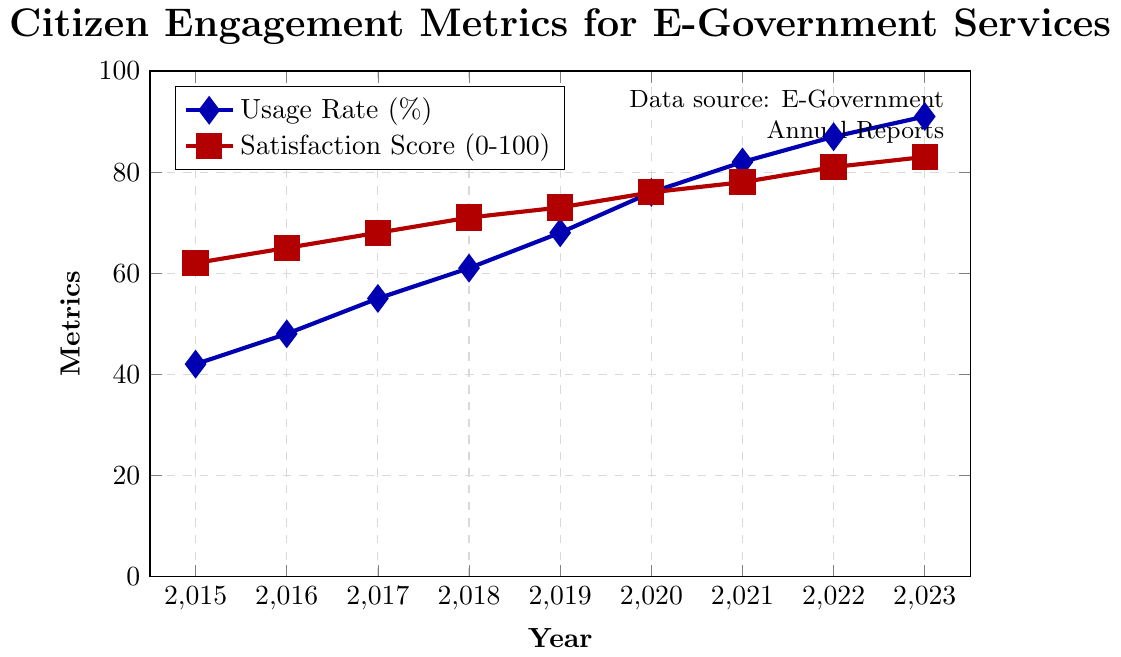What is the trend observed in the usage rate of e-government services from 2015 to 2023? Observing the blue line for Usage Rate (%), it shows a steady upward trend from 42% in 2015 to 91% in 2023. This indicates a consistent increase in usage rates over the years.
Answer: Steady upward trend Compare the Satisfaction Score of 2015 to that of 2023. The red line for Satisfaction Score in 2015 is at 62%, while in 2023 it reaches 83%. Hence, the satisfaction score increased by 21 percentage points over this period.
Answer: Increased by 21 percentage points Which year shows the highest increase in the usage rate as compared to the previous year? To find this, we calculate the year-over-year differences for Usage Rate (%) and compare them:
2015-2016: 48-42 = 6
2016-2017: 55-48 = 7
2017-2018: 61-55 = 6
2018-2019: 68-61 = 7
2019-2020: 76-68 = 8
2020-2021: 82-76 = 6
2021-2022: 87-82 = 5
2022-2023: 91-87 = 4
The highest increase is 8 percentage points from 2019 to 2020.
Answer: 2019 to 2020 By how much did the usage rate and satisfaction score improve from 2018 to 2023? Usage rate increased from 61% in 2018 to 91% in 2023, an increase of 30 percentage points. Satisfaction score increased from 71% in 2018 to 83% in 2023, an increase of 12 percentage points.
Answer: Usage Rate: 30 percentage points, Satisfaction Score: 12 percentage points Which data series shows a more pronounced increase visually? By comparing the slopes of the lines, the blue line (Usage Rate) shows a steeper and more pronounced increase compared to the red line (Satisfaction Score).
Answer: Usage Rate Calculate the average annual growth rate for the Satisfaction Score from 2015 to 2023. Growth rate can be computed as follows:
(83 - 62) / (2023 - 2015) = 21 / 8 ≈ 2.625 percentage points per year.
Answer: Approximately 2.625 percentage points per year Are the trends of Usage Rate and Satisfaction Score similar or different from 2015 to 2023? Both metrics show a steady increase over the years, indicating similar upward trends; however, the Usage Rate has a steeper increase compared to the Satisfaction Score.
Answer: Similar upward trends with steeper gain in Usage Rate 